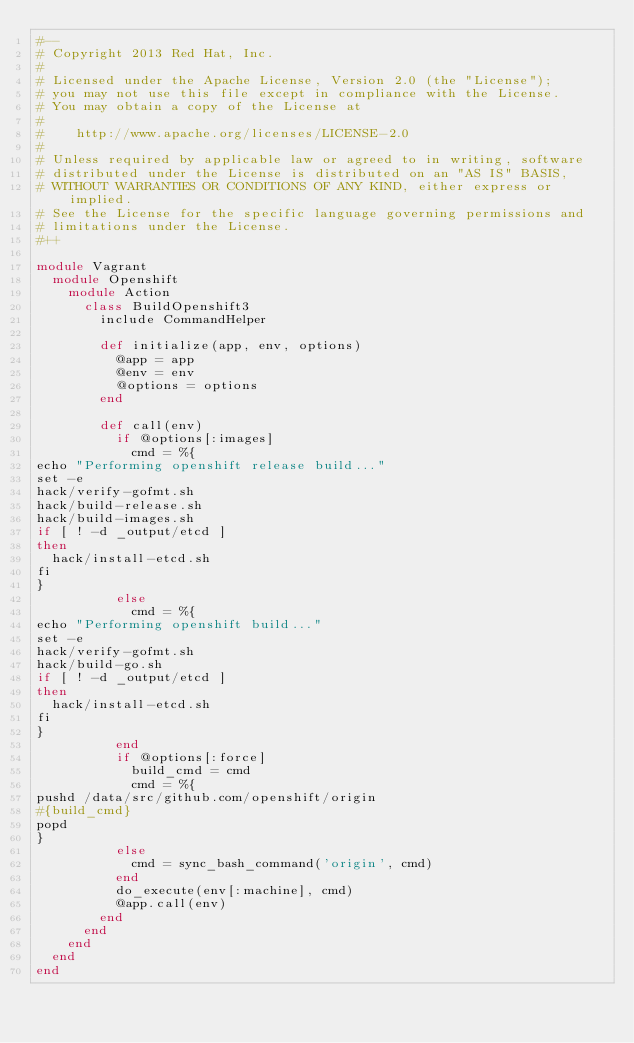<code> <loc_0><loc_0><loc_500><loc_500><_Ruby_>#--
# Copyright 2013 Red Hat, Inc.
#
# Licensed under the Apache License, Version 2.0 (the "License");
# you may not use this file except in compliance with the License.
# You may obtain a copy of the License at
#
#    http://www.apache.org/licenses/LICENSE-2.0
#
# Unless required by applicable law or agreed to in writing, software
# distributed under the License is distributed on an "AS IS" BASIS,
# WITHOUT WARRANTIES OR CONDITIONS OF ANY KIND, either express or implied.
# See the License for the specific language governing permissions and
# limitations under the License.
#++

module Vagrant
  module Openshift
    module Action
      class BuildOpenshift3
        include CommandHelper

        def initialize(app, env, options)
          @app = app
          @env = env
          @options = options
        end

        def call(env)
          if @options[:images]
            cmd = %{
echo "Performing openshift release build..."
set -e
hack/verify-gofmt.sh
hack/build-release.sh
hack/build-images.sh
if [ ! -d _output/etcd ]
then
  hack/install-etcd.sh
fi
}
          else
            cmd = %{
echo "Performing openshift build..."
set -e
hack/verify-gofmt.sh
hack/build-go.sh
if [ ! -d _output/etcd ]
then
  hack/install-etcd.sh
fi
}
          end
          if @options[:force]
            build_cmd = cmd
            cmd = %{
pushd /data/src/github.com/openshift/origin
#{build_cmd}
popd
}
          else
            cmd = sync_bash_command('origin', cmd)
          end
          do_execute(env[:machine], cmd) 
          @app.call(env)
        end
      end
    end
  end
end</code> 